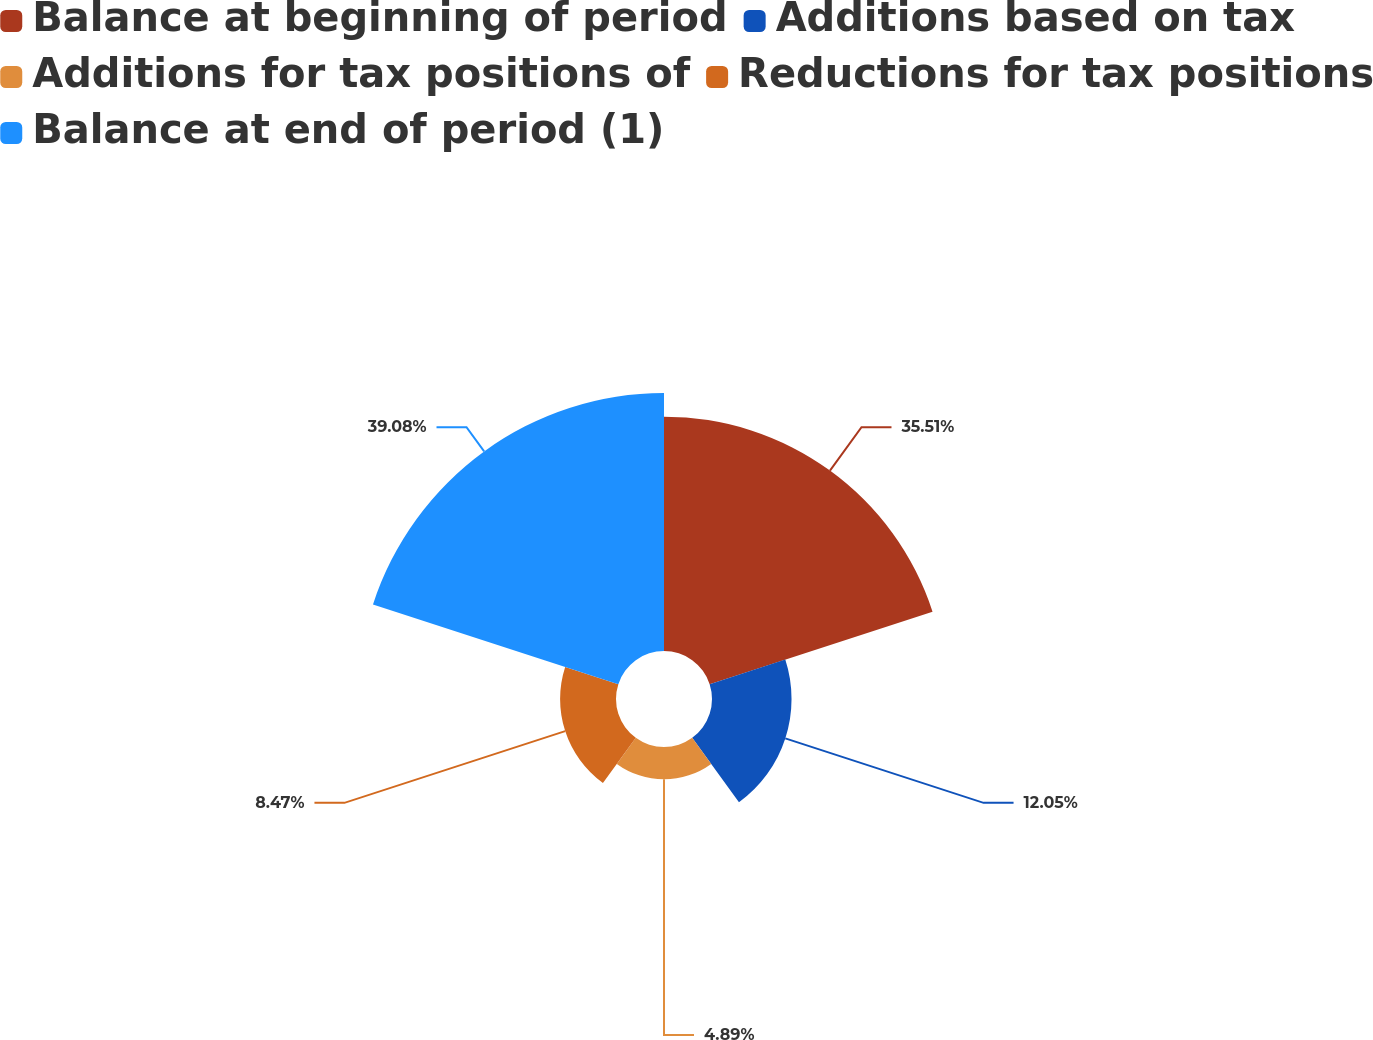<chart> <loc_0><loc_0><loc_500><loc_500><pie_chart><fcel>Balance at beginning of period<fcel>Additions based on tax<fcel>Additions for tax positions of<fcel>Reductions for tax positions<fcel>Balance at end of period (1)<nl><fcel>35.51%<fcel>12.05%<fcel>4.89%<fcel>8.47%<fcel>39.09%<nl></chart> 